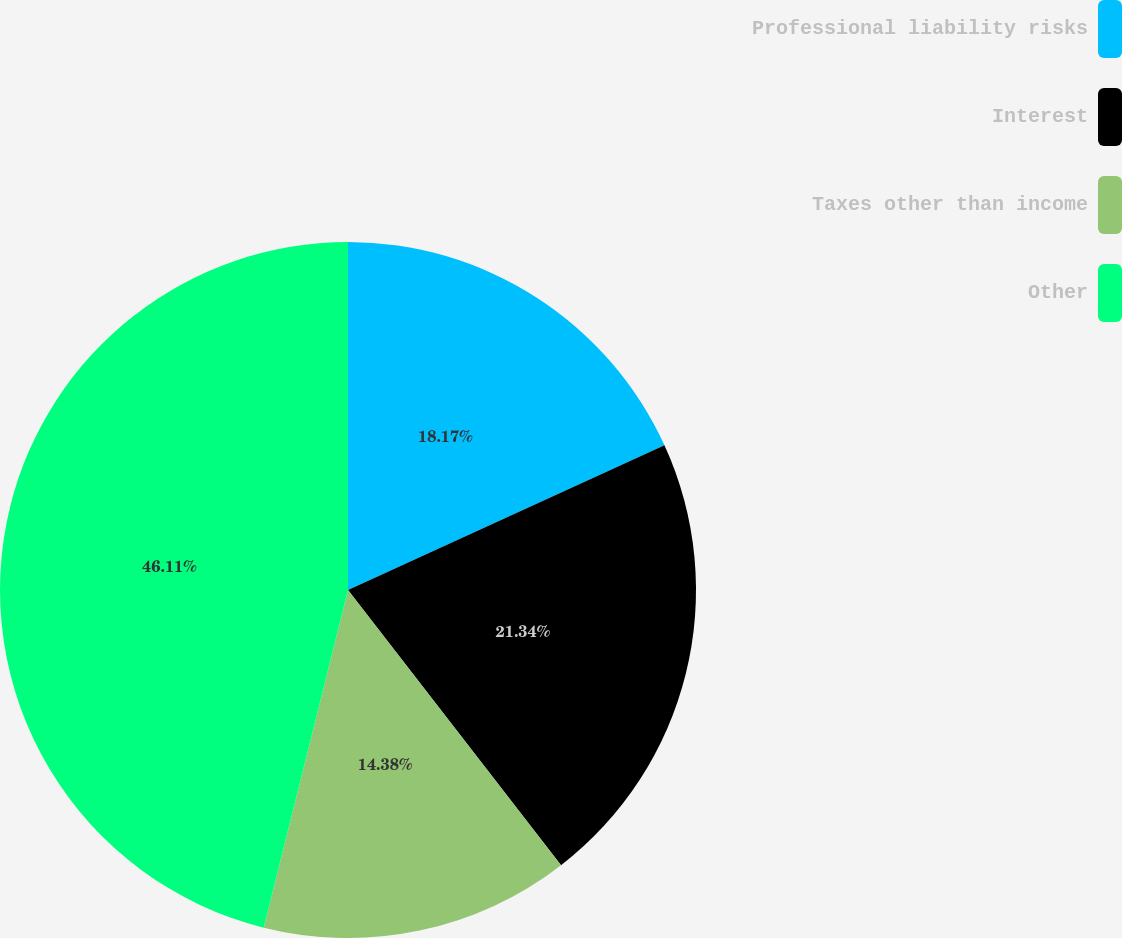<chart> <loc_0><loc_0><loc_500><loc_500><pie_chart><fcel>Professional liability risks<fcel>Interest<fcel>Taxes other than income<fcel>Other<nl><fcel>18.17%<fcel>21.34%<fcel>14.38%<fcel>46.1%<nl></chart> 